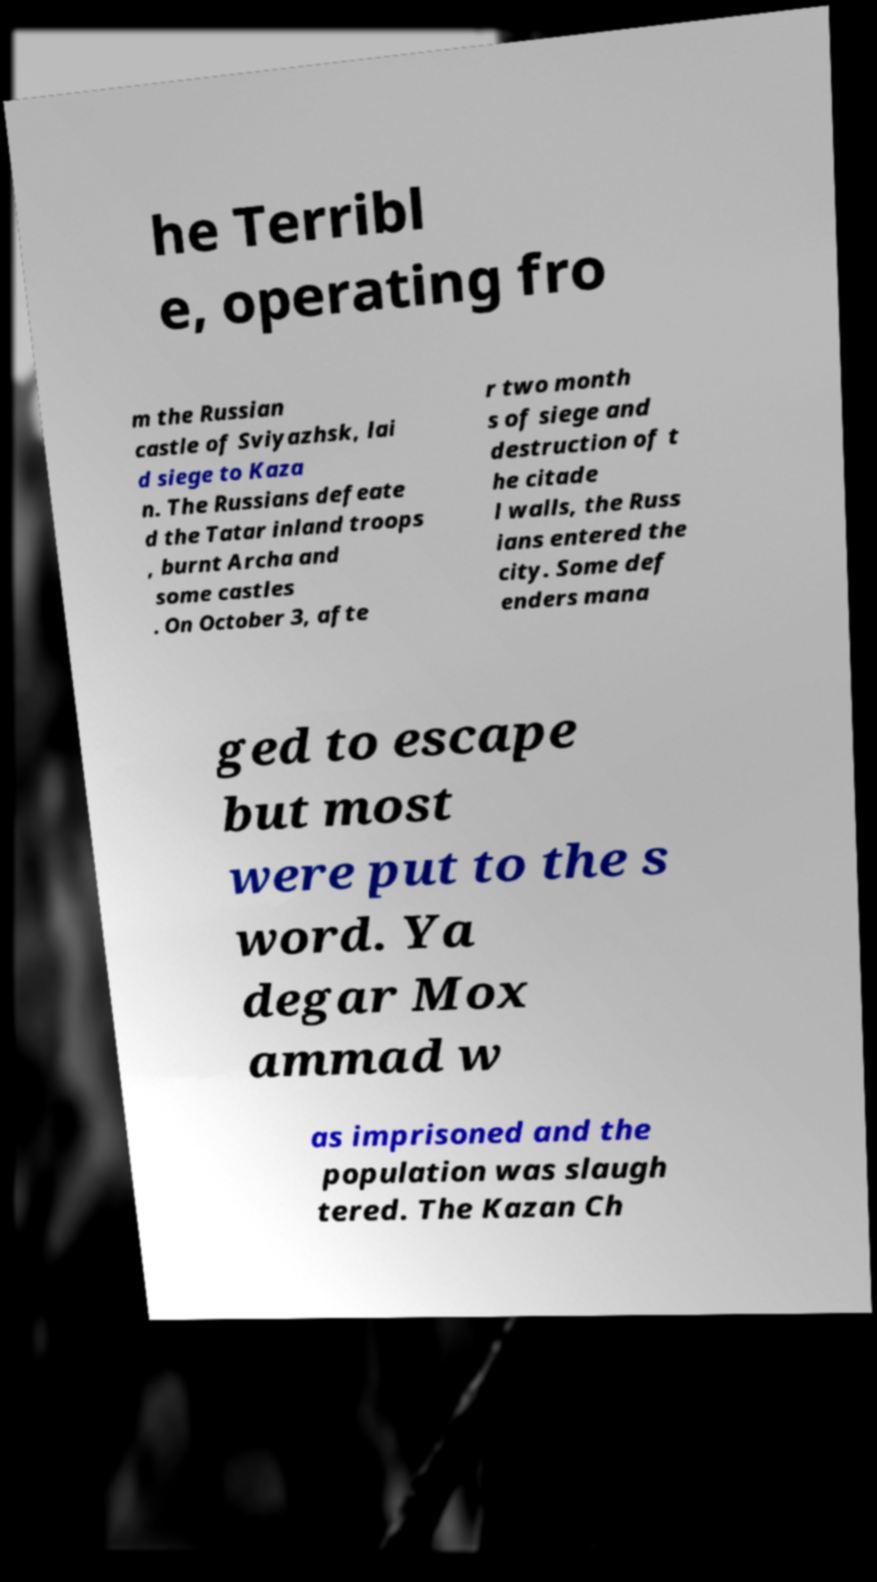I need the written content from this picture converted into text. Can you do that? he Terribl e, operating fro m the Russian castle of Sviyazhsk, lai d siege to Kaza n. The Russians defeate d the Tatar inland troops , burnt Archa and some castles . On October 3, afte r two month s of siege and destruction of t he citade l walls, the Russ ians entered the city. Some def enders mana ged to escape but most were put to the s word. Ya degar Mox ammad w as imprisoned and the population was slaugh tered. The Kazan Ch 